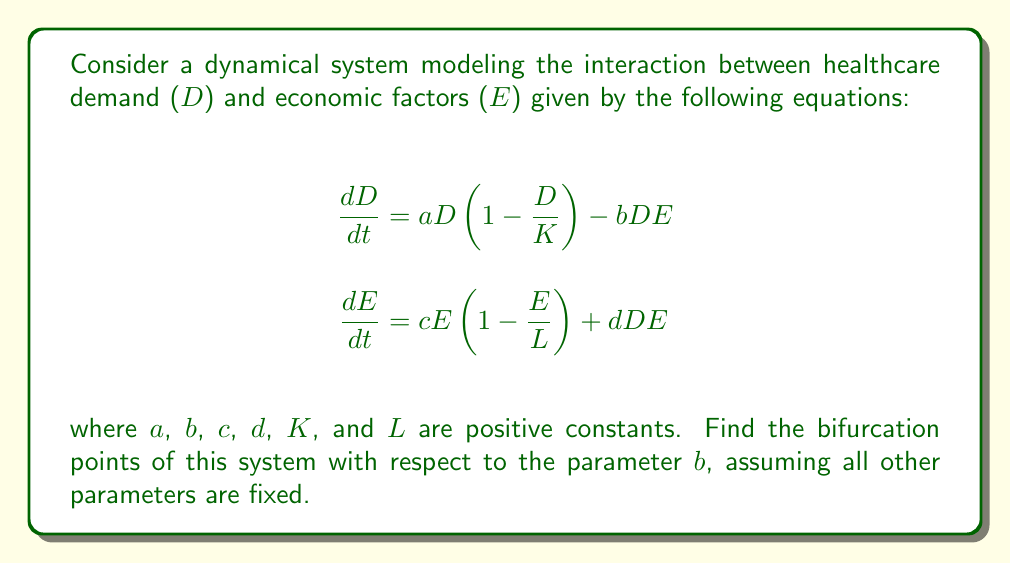Solve this math problem. To find the bifurcation points, we need to follow these steps:

1) First, find the equilibrium points by setting $\frac{dD}{dt} = 0$ and $\frac{dE}{dt} = 0$:

   $$aD(1-\frac{D}{K}) - bDE = 0$$
   $$cE(1-\frac{E}{L}) + dDE = 0$$

2) Solve these equations:
   
   From the first equation: $D = 0$ or $D = K(1-\frac{bE}{a})$
   From the second equation: $E = 0$ or $E = L(1+\frac{dD}{c})$

3) The equilibrium points are:
   
   $(0,0)$, $(K,0)$, $(0,L)$, and a non-trivial point $(D^*,E^*)$ where:
   
   $$D^* = \frac{K(a-bL)}{a-bL+dKL}$$
   $$E^* = \frac{L(c+dK)}{a-bL+dKL}$$

4) The non-trivial equilibrium exists only when $a > bL$. This gives us our first bifurcation point:

   $$b_1 = \frac{a}{L}$$

5) To find other bifurcation points, we need to analyze the stability of the equilibrium points. Let's focus on the non-trivial equilibrium. The Jacobian matrix at $(D^*,E^*)$ is:

   $$J = \begin{bmatrix}
   a(1-\frac{2D^*}{K}) - bE^* & -bD^* \\
   dE^* & c(1-\frac{2E^*}{L}) + dD^*
   \end{bmatrix}$$

6) For a bifurcation to occur, the real part of an eigenvalue of $J$ must change sign. This happens when $det(J) = 0$ or $tr(J) = 0$.

7) Solving $det(J) = 0$ gives us another bifurcation point:

   $$b_2 = \frac{a}{L} + \frac{c}{K} - \frac{2\sqrt{ac}}{KL}$$

8) Solving $tr(J) = 0$ doesn't give us a new bifurcation point in terms of $b$.

Therefore, we have found two bifurcation points: $b_1$ and $b_2$.
Answer: $b_1 = \frac{a}{L}$, $b_2 = \frac{a}{L} + \frac{c}{K} - \frac{2\sqrt{ac}}{KL}$ 